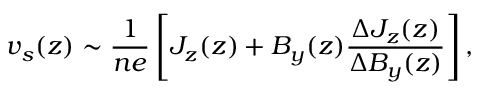<formula> <loc_0><loc_0><loc_500><loc_500>v _ { s } ( z ) \sim \frac { 1 } { n e } \left [ J _ { z } ( z ) + B _ { y } ( z ) \frac { \Delta J _ { z } ( z ) } { \Delta B _ { y } ( z ) } \right ] ,</formula> 